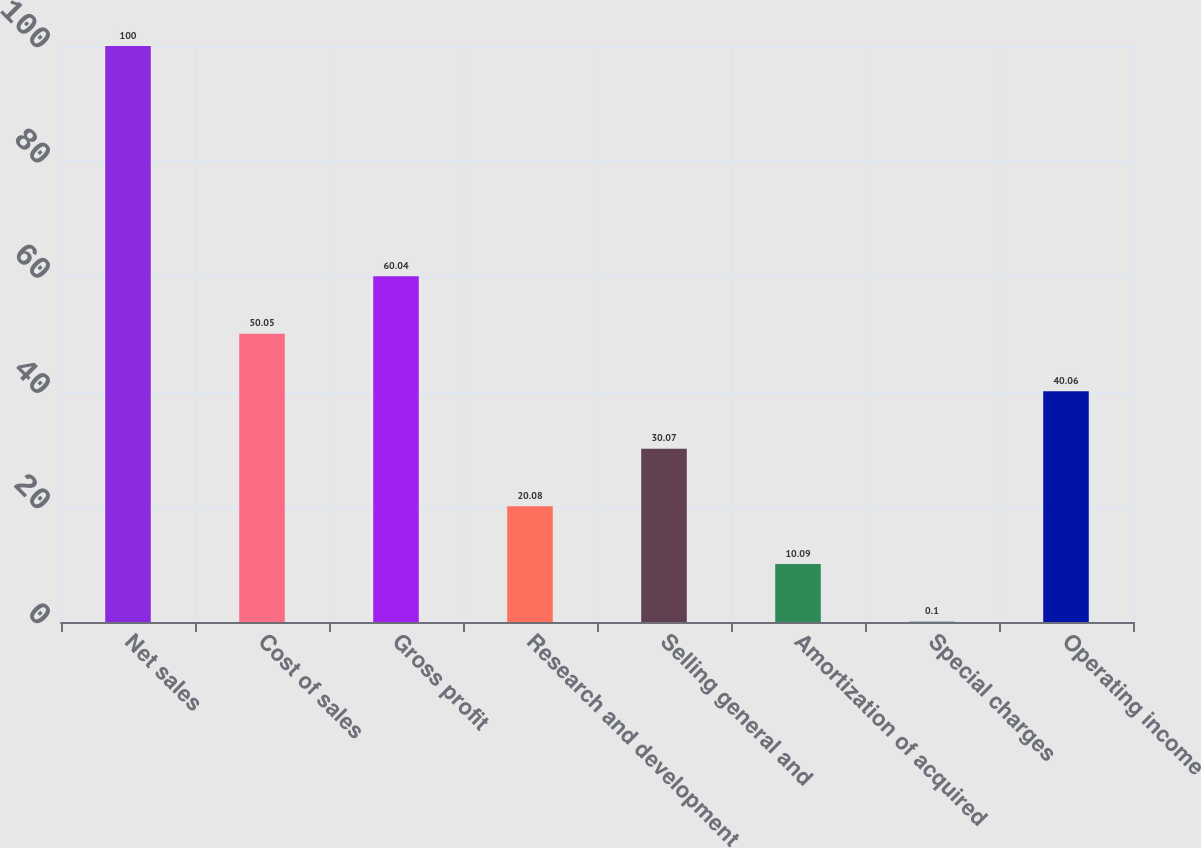<chart> <loc_0><loc_0><loc_500><loc_500><bar_chart><fcel>Net sales<fcel>Cost of sales<fcel>Gross profit<fcel>Research and development<fcel>Selling general and<fcel>Amortization of acquired<fcel>Special charges<fcel>Operating income<nl><fcel>100<fcel>50.05<fcel>60.04<fcel>20.08<fcel>30.07<fcel>10.09<fcel>0.1<fcel>40.06<nl></chart> 